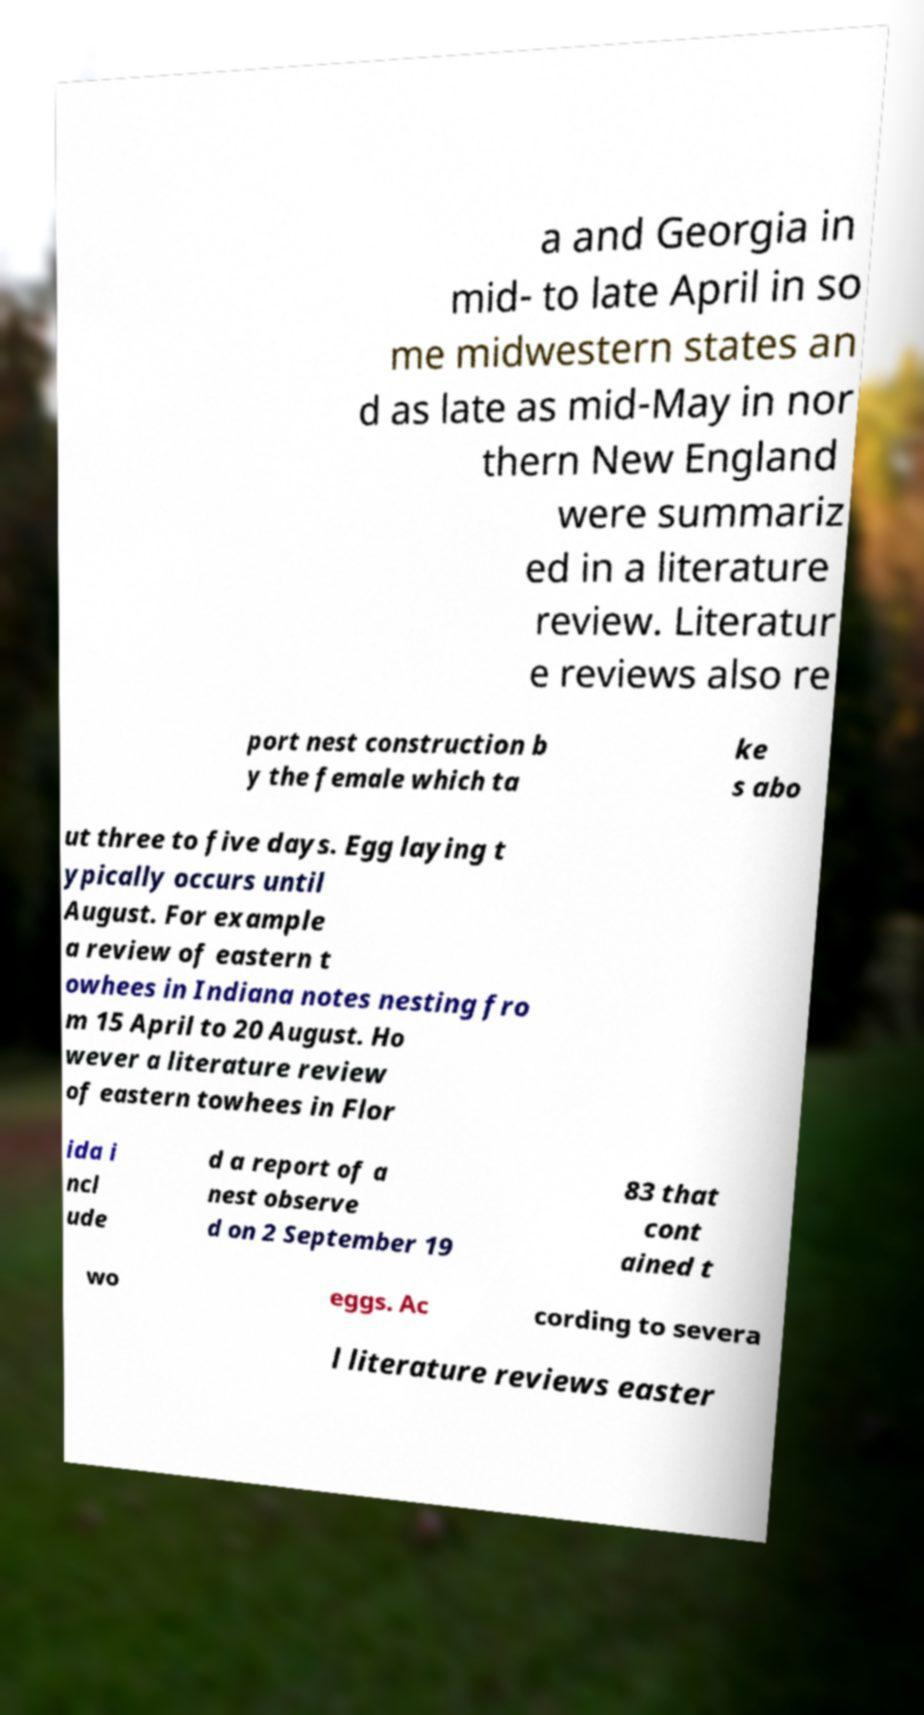I need the written content from this picture converted into text. Can you do that? a and Georgia in mid- to late April in so me midwestern states an d as late as mid-May in nor thern New England were summariz ed in a literature review. Literatur e reviews also re port nest construction b y the female which ta ke s abo ut three to five days. Egg laying t ypically occurs until August. For example a review of eastern t owhees in Indiana notes nesting fro m 15 April to 20 August. Ho wever a literature review of eastern towhees in Flor ida i ncl ude d a report of a nest observe d on 2 September 19 83 that cont ained t wo eggs. Ac cording to severa l literature reviews easter 